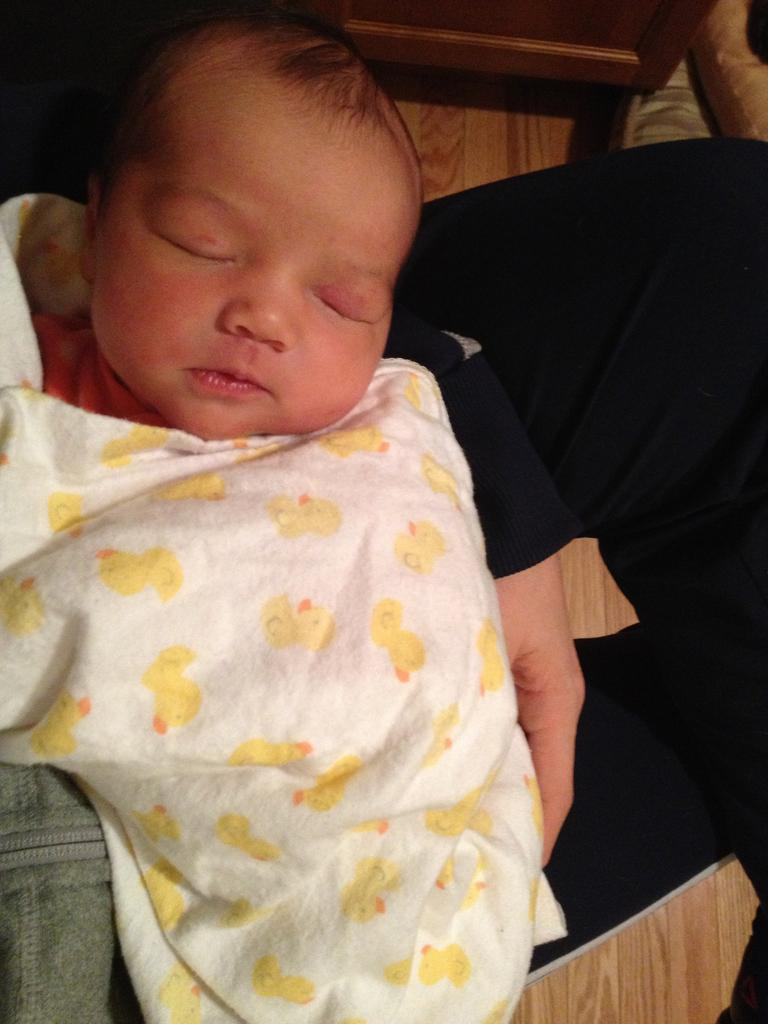What is the main subject of the image? There is a baby in the image. What is the baby doing in the image? The baby is sleeping on the bed. Is the baby covered by anything in the image? Yes, there is a blanket covering the baby. What type of vase can be seen next to the baby in the image? There is no vase present in the image; it only features a baby sleeping on the bed with a blanket covering them. 